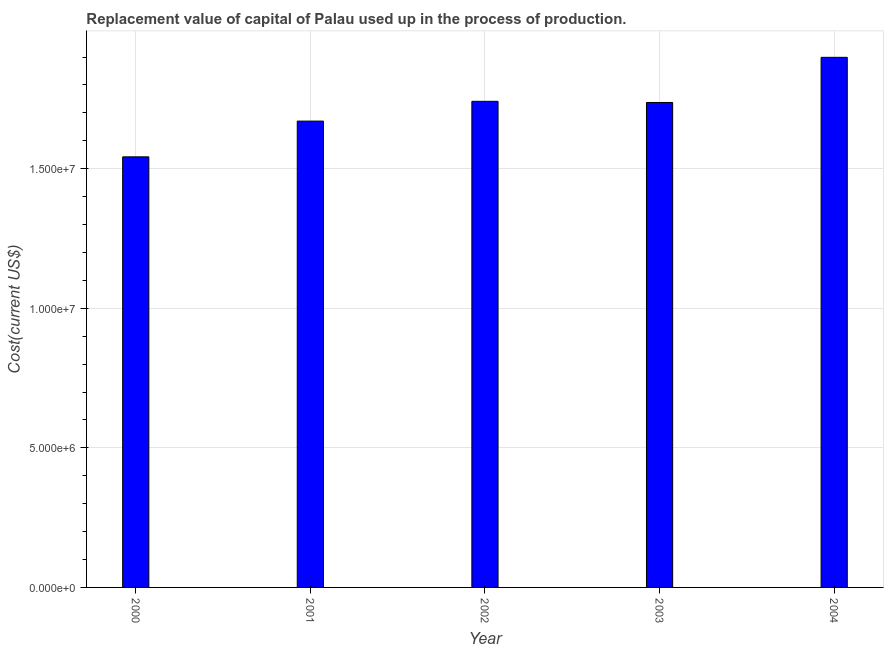What is the title of the graph?
Offer a terse response. Replacement value of capital of Palau used up in the process of production. What is the label or title of the Y-axis?
Provide a succinct answer. Cost(current US$). What is the consumption of fixed capital in 2002?
Keep it short and to the point. 1.74e+07. Across all years, what is the maximum consumption of fixed capital?
Offer a terse response. 1.90e+07. Across all years, what is the minimum consumption of fixed capital?
Provide a short and direct response. 1.54e+07. In which year was the consumption of fixed capital minimum?
Give a very brief answer. 2000. What is the sum of the consumption of fixed capital?
Keep it short and to the point. 8.59e+07. What is the difference between the consumption of fixed capital in 2002 and 2003?
Your answer should be compact. 4.14e+04. What is the average consumption of fixed capital per year?
Provide a short and direct response. 1.72e+07. What is the median consumption of fixed capital?
Offer a terse response. 1.74e+07. What is the ratio of the consumption of fixed capital in 2000 to that in 2001?
Provide a short and direct response. 0.92. Is the consumption of fixed capital in 2001 less than that in 2004?
Make the answer very short. Yes. Is the difference between the consumption of fixed capital in 2001 and 2003 greater than the difference between any two years?
Your response must be concise. No. What is the difference between the highest and the second highest consumption of fixed capital?
Your answer should be compact. 1.58e+06. Is the sum of the consumption of fixed capital in 2000 and 2002 greater than the maximum consumption of fixed capital across all years?
Give a very brief answer. Yes. What is the difference between the highest and the lowest consumption of fixed capital?
Your answer should be compact. 3.56e+06. Are all the bars in the graph horizontal?
Provide a succinct answer. No. How many years are there in the graph?
Your answer should be very brief. 5. What is the Cost(current US$) in 2000?
Offer a terse response. 1.54e+07. What is the Cost(current US$) of 2001?
Your response must be concise. 1.67e+07. What is the Cost(current US$) in 2002?
Give a very brief answer. 1.74e+07. What is the Cost(current US$) of 2003?
Your answer should be compact. 1.74e+07. What is the Cost(current US$) of 2004?
Provide a succinct answer. 1.90e+07. What is the difference between the Cost(current US$) in 2000 and 2001?
Keep it short and to the point. -1.28e+06. What is the difference between the Cost(current US$) in 2000 and 2002?
Your response must be concise. -1.99e+06. What is the difference between the Cost(current US$) in 2000 and 2003?
Provide a succinct answer. -1.95e+06. What is the difference between the Cost(current US$) in 2000 and 2004?
Offer a terse response. -3.56e+06. What is the difference between the Cost(current US$) in 2001 and 2002?
Your answer should be compact. -7.08e+05. What is the difference between the Cost(current US$) in 2001 and 2003?
Your answer should be compact. -6.67e+05. What is the difference between the Cost(current US$) in 2001 and 2004?
Offer a very short reply. -2.28e+06. What is the difference between the Cost(current US$) in 2002 and 2003?
Your answer should be very brief. 4.14e+04. What is the difference between the Cost(current US$) in 2002 and 2004?
Offer a terse response. -1.58e+06. What is the difference between the Cost(current US$) in 2003 and 2004?
Make the answer very short. -1.62e+06. What is the ratio of the Cost(current US$) in 2000 to that in 2001?
Your answer should be compact. 0.92. What is the ratio of the Cost(current US$) in 2000 to that in 2002?
Keep it short and to the point. 0.89. What is the ratio of the Cost(current US$) in 2000 to that in 2003?
Offer a terse response. 0.89. What is the ratio of the Cost(current US$) in 2000 to that in 2004?
Ensure brevity in your answer.  0.81. What is the ratio of the Cost(current US$) in 2001 to that in 2003?
Offer a terse response. 0.96. What is the ratio of the Cost(current US$) in 2001 to that in 2004?
Provide a short and direct response. 0.88. What is the ratio of the Cost(current US$) in 2002 to that in 2004?
Your answer should be compact. 0.92. What is the ratio of the Cost(current US$) in 2003 to that in 2004?
Offer a terse response. 0.92. 